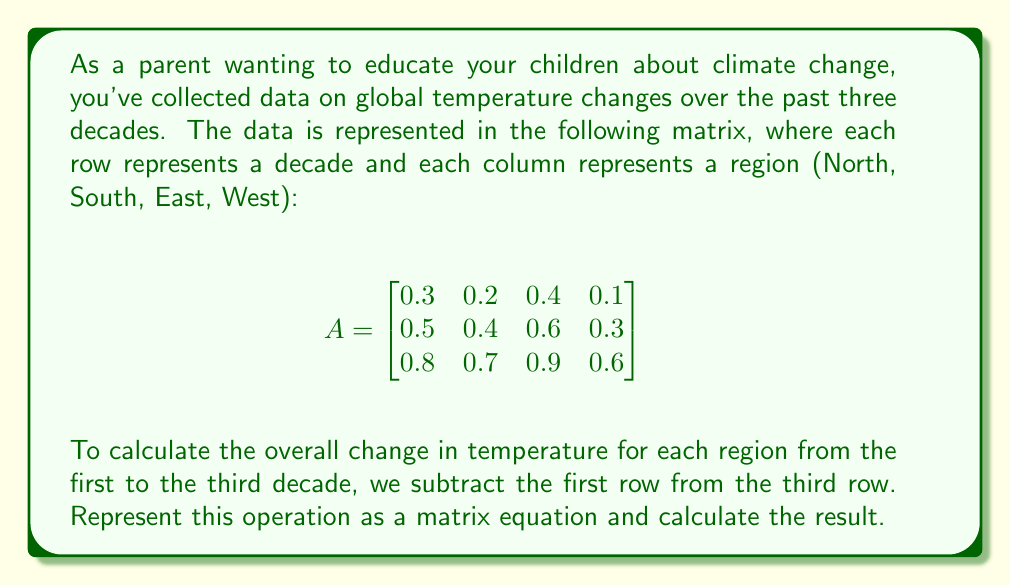Teach me how to tackle this problem. Let's approach this step-by-step:

1) We need to subtract the first row from the third row. We can represent this operation as a matrix equation:

   $$B = \begin{bmatrix}
   0 & 0 & 0 & 0 \\
   0 & 0 & 0 & 0 \\
   1 & 1 & 1 & 1 \\
   \end{bmatrix} - 
   \begin{bmatrix}
   1 & 1 & 1 & 1 \\
   0 & 0 & 0 & 0 \\
   0 & 0 & 0 & 0 \\
   \end{bmatrix}$$

2) This results in the matrix B:

   $$B = \begin{bmatrix}
   -1 & -1 & -1 & -1 \\
   0 & 0 & 0 & 0 \\
   1 & 1 & 1 & 1 \\
   \end{bmatrix}$$

3) Now, we can multiply our original matrix A by B:

   $$BA = \begin{bmatrix}
   -1 & -1 & -1 & -1 \\
   0 & 0 & 0 & 0 \\
   1 & 1 & 1 & 1 \\
   \end{bmatrix}
   \begin{bmatrix}
   0.3 & 0.2 & 0.4 & 0.1 \\
   0.5 & 0.4 & 0.6 & 0.3 \\
   0.8 & 0.7 & 0.9 & 0.6
   \end{bmatrix}$$

4) Performing the matrix multiplication:

   $$BA = \begin{bmatrix}
   (-0.3 + 0.8) & (-0.2 + 0.7) & (-0.4 + 0.9) & (-0.1 + 0.6) \\
   \end{bmatrix}$$

5) Simplifying:

   $$BA = \begin{bmatrix}
   0.5 & 0.5 & 0.5 & 0.5
   \end{bmatrix}$$

This result shows the temperature change for each region from the first to the third decade.
Answer: $$\begin{bmatrix} 0.5 & 0.5 & 0.5 & 0.5 \end{bmatrix}$$ 